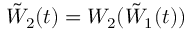Convert formula to latex. <formula><loc_0><loc_0><loc_500><loc_500>\tilde { W } _ { 2 } ( t ) = W _ { 2 } ( \tilde { W } _ { 1 } ( t ) )</formula> 